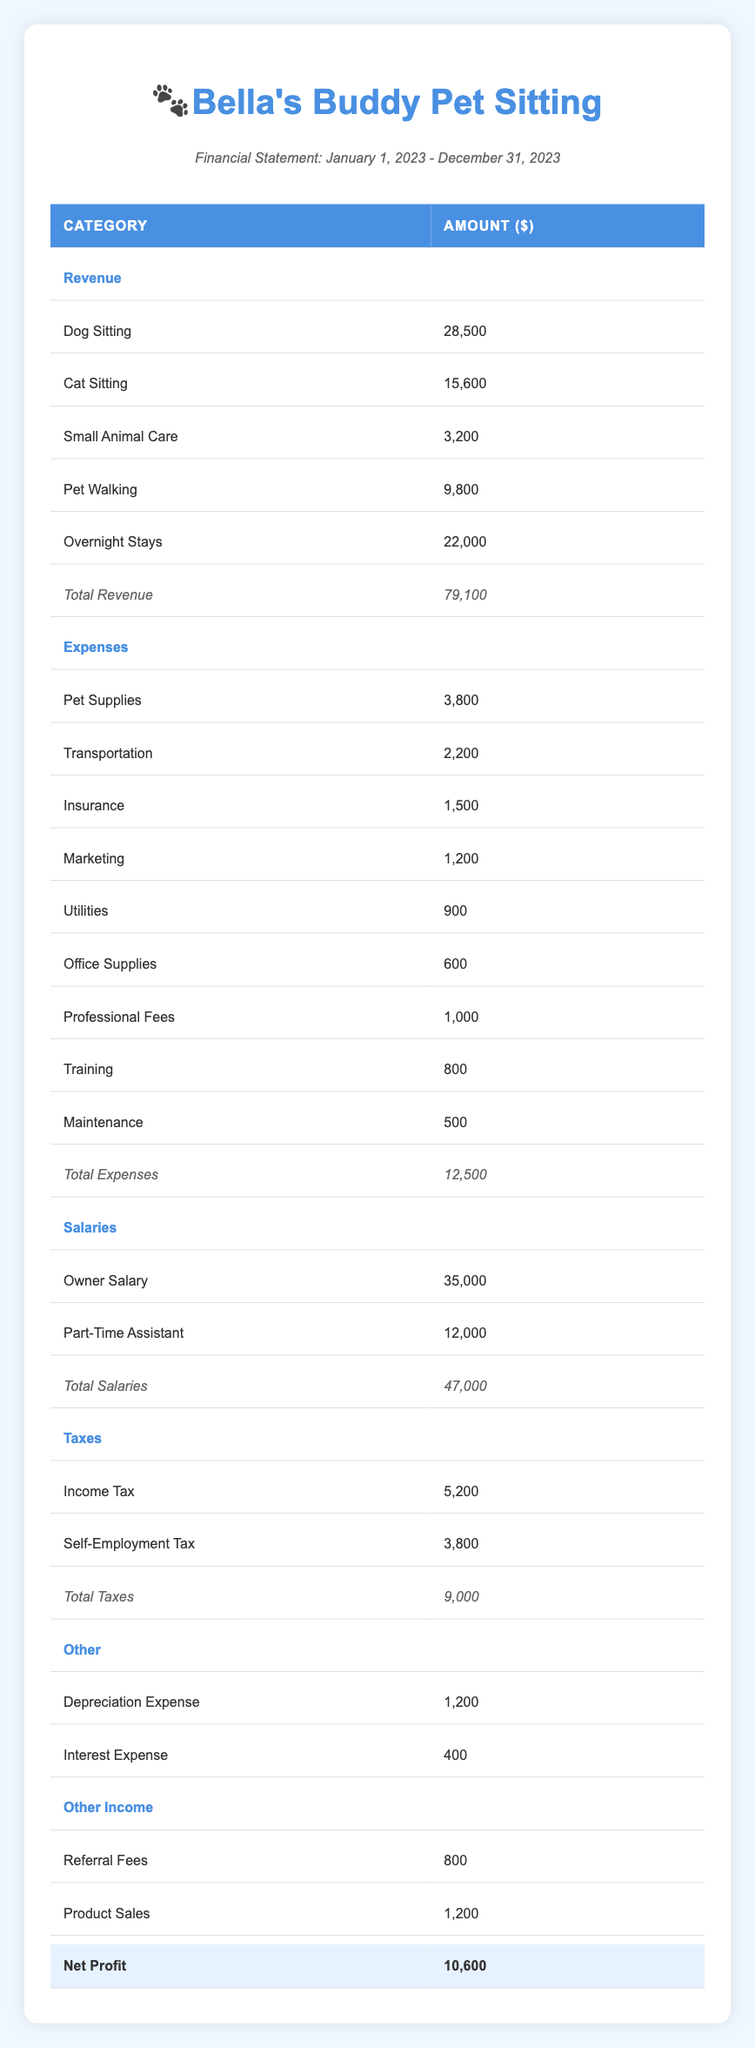What is the total revenue for Bella's Buddy Pet Sitting? The total revenue is given in the table as a subtotal after listing all revenue sources. The amounts for each service are: dog sitting (28,500), cat sitting (15,600), small animal care (3,200), pet walking (9,800), and overnight stays (22,000). Summing these gives 79,100.
Answer: 79,100 What are the total expenses incurred by the business? The total expenses are presented as a subtotal at the end of the expenses section. Summing up the listed expenses (pet supplies, transportation, insurance, marketing, utilities, office supplies, professional fees, training, maintenance) equals 12,500.
Answer: 12,500 Is the owner’s salary higher than the part-time assistant’s salary? Comparing the owner salary (35,000) to the part-time assistant salary (12,000) shows that the owner's salary is greater.
Answer: Yes What is the net profit calculated by Bella's Buddy Pet Sitting? The net profit is indicated at the bottom of the table as the final figure, which is 10,600.
Answer: 10,600 What is the sum of all tax expenses? To determine the sum of the tax expenses, add the income tax (5,200) and the self-employment tax (3,800) together. This equals 9,000.
Answer: 9,000 What is the overall total amount spent on salaries? The table lists the owner’s salary (35,000) and the part-time assistant’s salary (12,000). Adding these two amounts together (35,000 + 12,000) gives the total salaries of 47,000.
Answer: 47,000 Did Bella’s Buddy Pet Sitting earn any income from referral fees? The table mentions referral fees as a source of other income with an amount of 800, indicating that referral fees were indeed earned.
Answer: Yes How much was spent on insurance compared to marketing expenses? The insurance expense is 1,500, while the marketing expense is 1,200. Since 1,500 is greater than 1,200, more was spent on insurance than on marketing.
Answer: More was spent on insurance What is the total of other income sources listed? The other income comprises referral fees (800) and product sales (1,200). Adding these amounts (800 + 1,200) results in a total of 2,000 from other income sources.
Answer: 2,000 